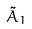<formula> <loc_0><loc_0><loc_500><loc_500>\tilde { A } _ { 1 }</formula> 